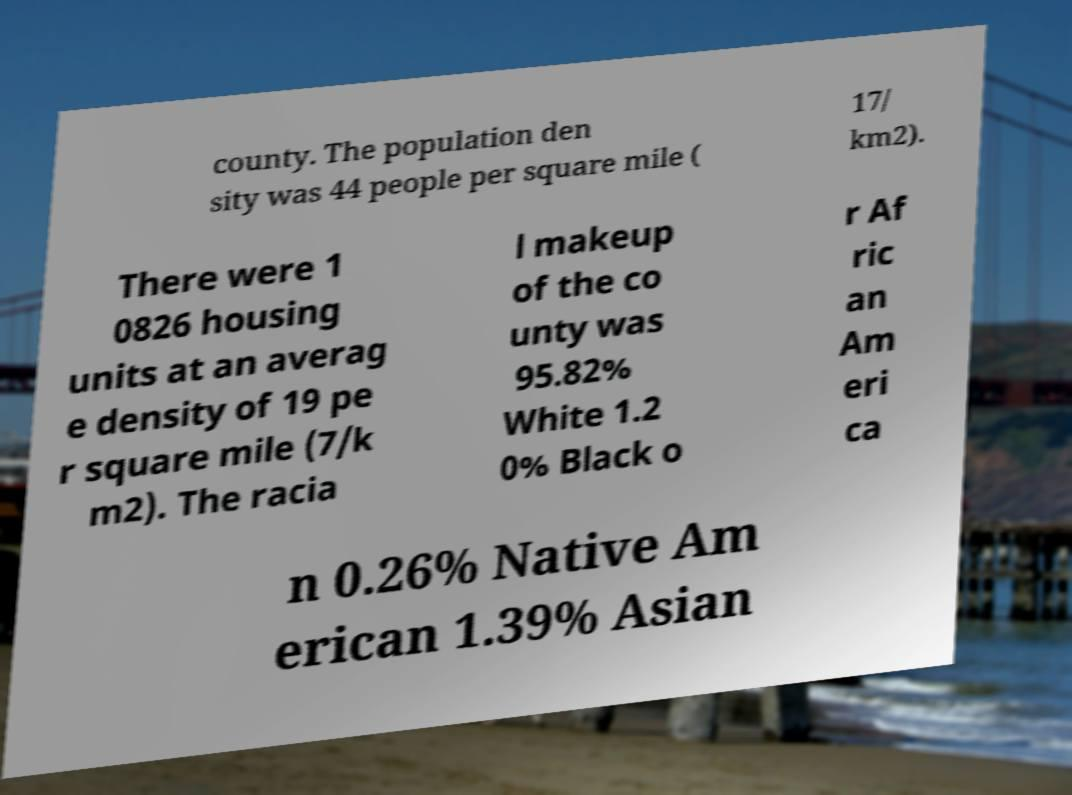Could you assist in decoding the text presented in this image and type it out clearly? county. The population den sity was 44 people per square mile ( 17/ km2). There were 1 0826 housing units at an averag e density of 19 pe r square mile (7/k m2). The racia l makeup of the co unty was 95.82% White 1.2 0% Black o r Af ric an Am eri ca n 0.26% Native Am erican 1.39% Asian 